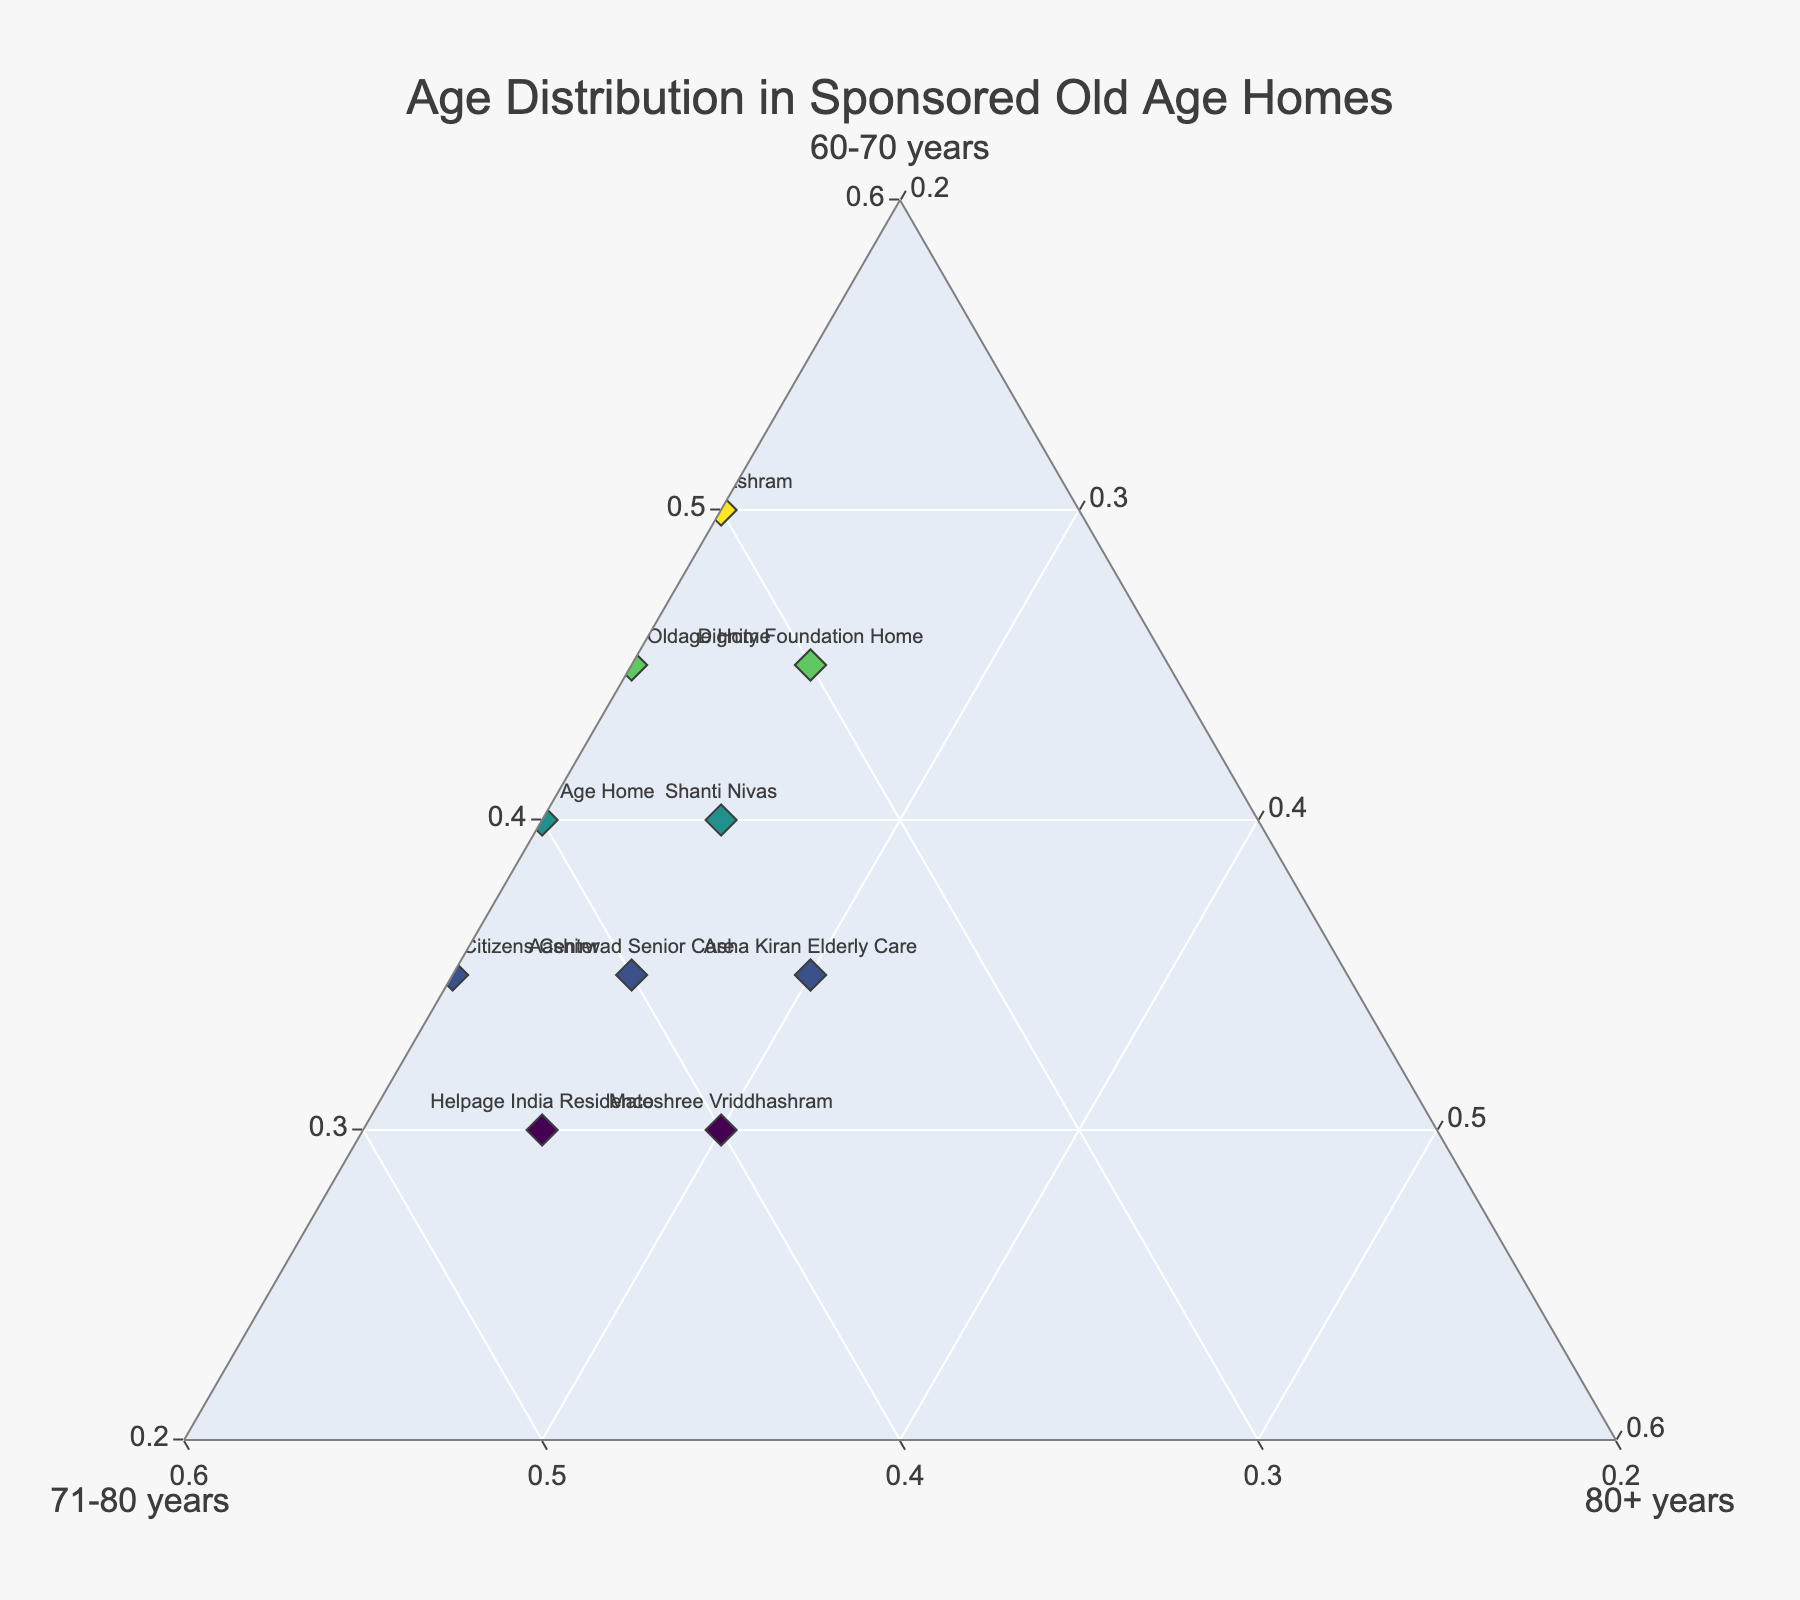What is the title of the ternary plot? The title is positioned at the top of the plot and denotes the main topic or theme of the figure. It is labeled clearly in the center.
Answer: Age Distribution in Sponsored Old Age Homes How many old age homes are represented in the ternary plot? The data points in the plot each represent a distinct old age home. Count the number of unique labels or markers.
Answer: 10 Which old age home has the highest proportion of residents aged 60-70 years? Identify the marker closest to the corner of the ternary plot labeled "60-70 years". Look for the label attached to this marker.
Answer: Ananda Ashram What is the range of values for the proportion of residents aged 71-80 years? Observe the points along the axis labeled "71-80 years". The axis helps determine the minimum and maximum proportions seen along this dimension.
Answer: 30% to 45% Which old age homes have an equal proportion of residents aged 60-70 and 71-80 years? Look for the markers aligned diagonally between the "60-70 years" and "71-80 years" axes. Check the labels of these markers.
Answer: Asha Kiran Elderly Care, Vishranthi Old Age Home Which old age home has the smallest proportion of residents aged 80+ years? Identify the marker nearest to the edge opposite the "80+ years" corner. The label on this marker specifies the old age home.
Answer: Ananda Ashram Among the old age homes, which one has the most balanced age distribution across the three age groups? Look for the marker located closest to the centroid of the ternary plot. This indicates a similar proportion in all three age groups.
Answer: Asha Kiran Elderly Care What is the overall proportion of residents aged 60-70 years in "Matoshree Vriddhashram"? Locate the marker for "Matoshree Vriddhashram" and read off its position from the "60-70 years" axis.
Answer: 30% Compare the proportions of residents aged 71-80 years between "Panchvati Senior Citizens Center" and "Dignity Foundation Home". Which has the higher proportion and by how much? Observe the positions of the markers for both centers on the "71-80 years" axis. Subtract the proportion of "Dignity Foundation Home" from that of "Panchvati Senior Citizens Center".
Answer: Panchvati Senior Citizens Center; 15% higher Which old age home has the highest marker color intensity, and what does this represent? Identify the marker with the darkest shade. This indicates the highest proportion of residents aged 60-70 years.
Answer: Ananda Ashram 